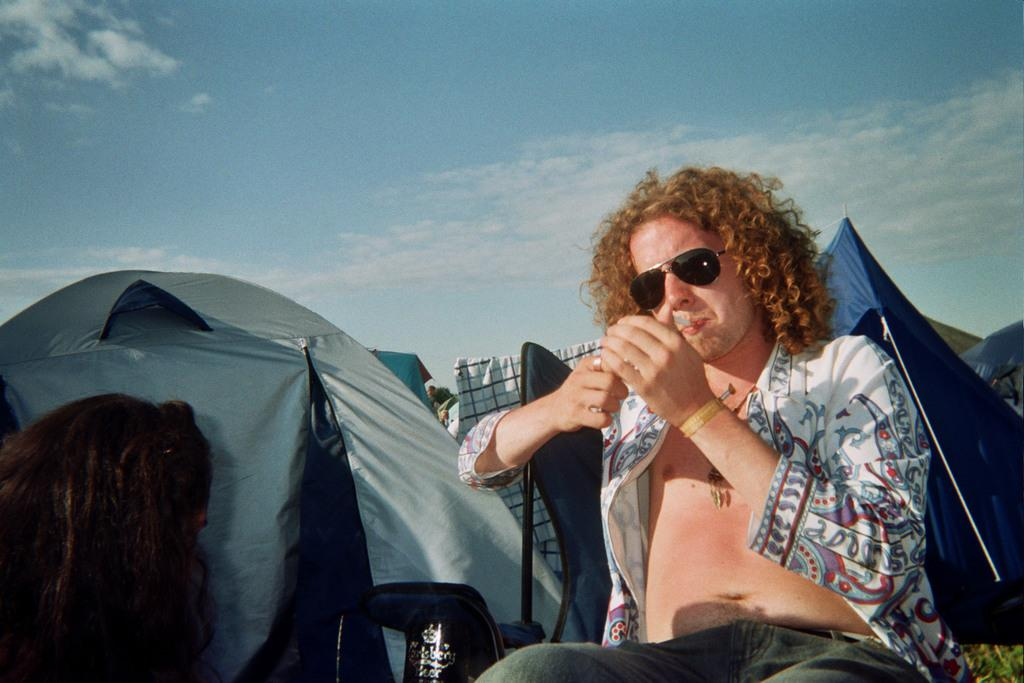What is the man in the image doing? The man is sitting on a chair in the image. Who is in front of the man? There is another person in front of the man. What type of temporary shelter can be seen in the image? Tents are visible in the image. What type of items are present in the image? Clothes are present in the image. What can be seen in the background of the image? The sky is visible in the background of the image. What type of crack can be seen in the image? There is no crack present in the image. 